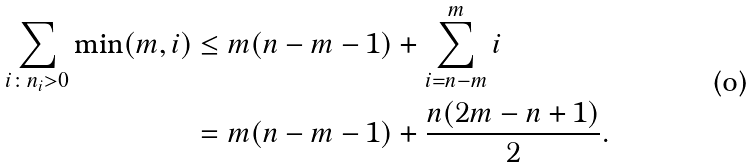<formula> <loc_0><loc_0><loc_500><loc_500>\sum _ { i \colon n _ { i } > 0 } \min ( m , i ) & \leq m ( n - m - 1 ) + \sum _ { i = n - m } ^ { m } i \\ & = m ( n - m - 1 ) + \frac { n ( 2 m - n + 1 ) } { 2 } .</formula> 